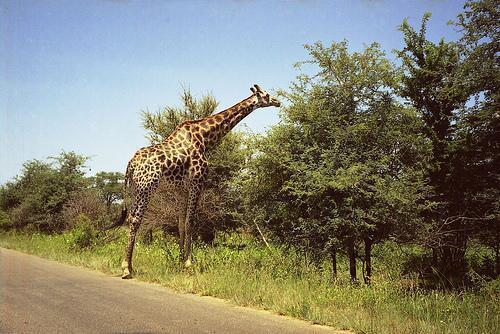How many trees are to the right of the giraffe?
Give a very brief answer. 4. 